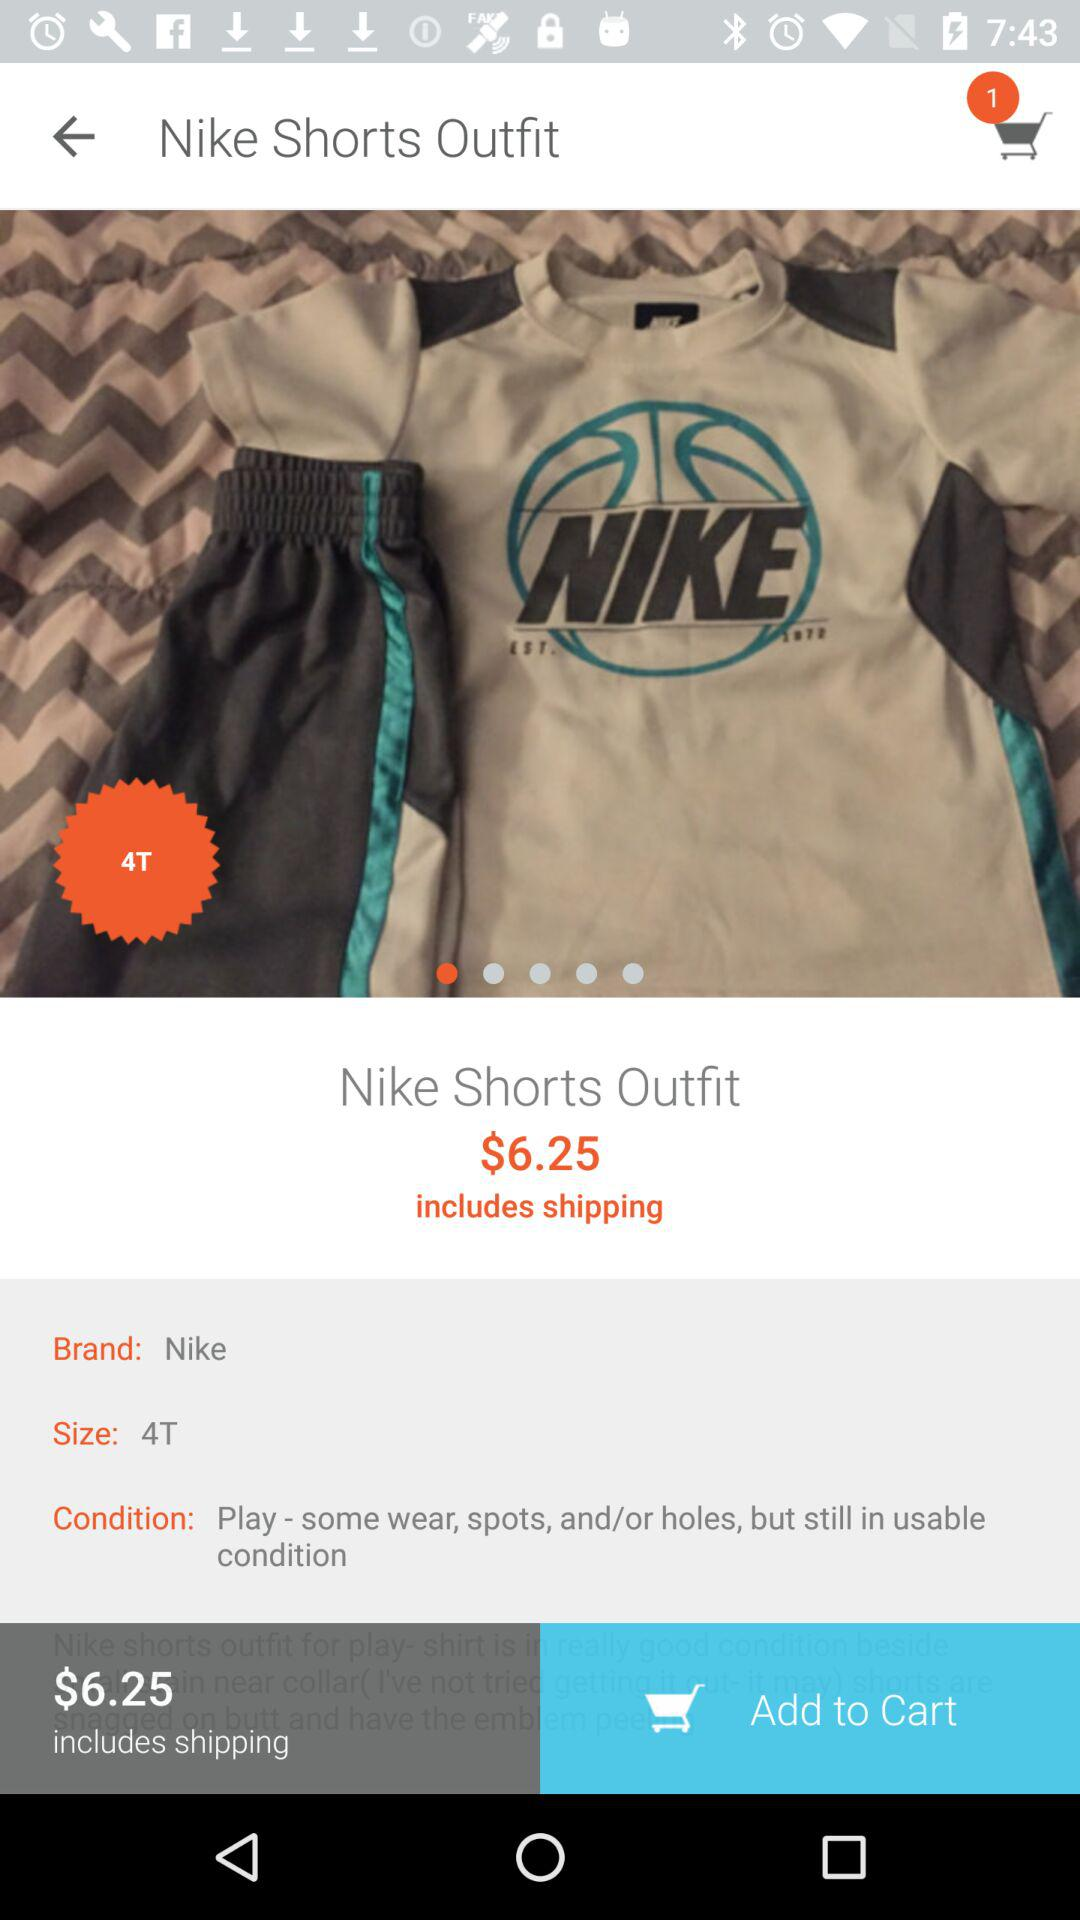What is the price of the Nike shorts outfit? The price of the Nike shorts outfit is $6.25. 